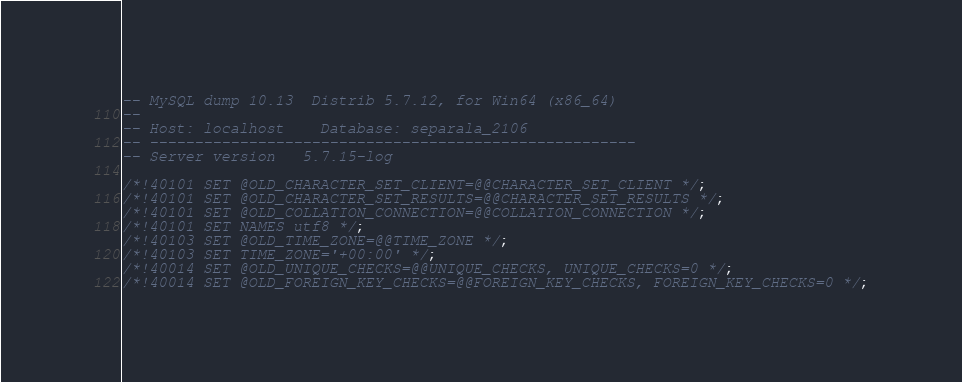Convert code to text. <code><loc_0><loc_0><loc_500><loc_500><_SQL_>-- MySQL dump 10.13  Distrib 5.7.12, for Win64 (x86_64)
--
-- Host: localhost    Database: separala_2106
-- ------------------------------------------------------
-- Server version	5.7.15-log

/*!40101 SET @OLD_CHARACTER_SET_CLIENT=@@CHARACTER_SET_CLIENT */;
/*!40101 SET @OLD_CHARACTER_SET_RESULTS=@@CHARACTER_SET_RESULTS */;
/*!40101 SET @OLD_COLLATION_CONNECTION=@@COLLATION_CONNECTION */;
/*!40101 SET NAMES utf8 */;
/*!40103 SET @OLD_TIME_ZONE=@@TIME_ZONE */;
/*!40103 SET TIME_ZONE='+00:00' */;
/*!40014 SET @OLD_UNIQUE_CHECKS=@@UNIQUE_CHECKS, UNIQUE_CHECKS=0 */;
/*!40014 SET @OLD_FOREIGN_KEY_CHECKS=@@FOREIGN_KEY_CHECKS, FOREIGN_KEY_CHECKS=0 */;</code> 